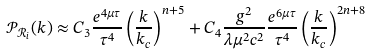Convert formula to latex. <formula><loc_0><loc_0><loc_500><loc_500>\mathcal { P } _ { \mathcal { R } _ { i } } ( k ) \approx C _ { 3 } \frac { e ^ { 4 \mu \tau } } { \tau ^ { 4 } } \left ( \frac { k } { k _ { c } } \right ) ^ { n + 5 } + C _ { 4 } \frac { g ^ { 2 } } { \lambda \mu ^ { 2 } c ^ { 2 } } \frac { e ^ { 6 \mu \tau } } { \tau ^ { 4 } } \left ( \frac { k } { k _ { c } } \right ) ^ { 2 n + 8 }</formula> 